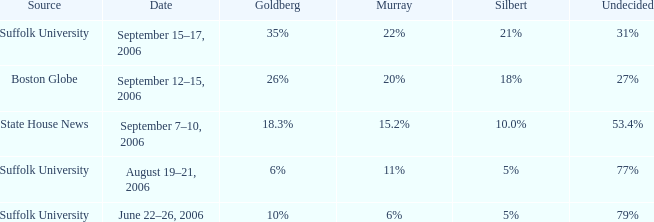What is the undetermined percentage of the suffolk university poll with murray at 11%? 77%. 